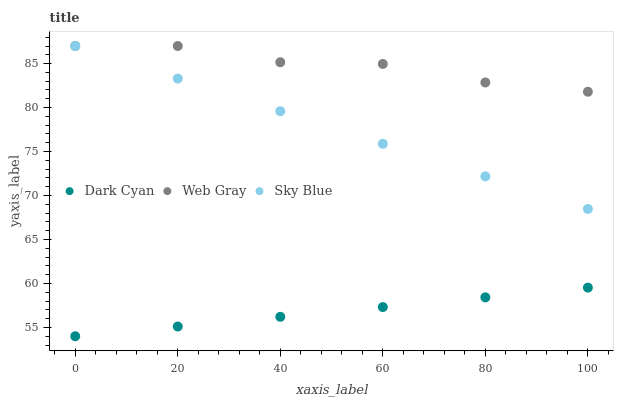Does Dark Cyan have the minimum area under the curve?
Answer yes or no. Yes. Does Web Gray have the maximum area under the curve?
Answer yes or no. Yes. Does Sky Blue have the minimum area under the curve?
Answer yes or no. No. Does Sky Blue have the maximum area under the curve?
Answer yes or no. No. Is Sky Blue the smoothest?
Answer yes or no. Yes. Is Web Gray the roughest?
Answer yes or no. Yes. Is Web Gray the smoothest?
Answer yes or no. No. Is Sky Blue the roughest?
Answer yes or no. No. Does Dark Cyan have the lowest value?
Answer yes or no. Yes. Does Sky Blue have the lowest value?
Answer yes or no. No. Does Web Gray have the highest value?
Answer yes or no. Yes. Is Dark Cyan less than Sky Blue?
Answer yes or no. Yes. Is Web Gray greater than Dark Cyan?
Answer yes or no. Yes. Does Web Gray intersect Sky Blue?
Answer yes or no. Yes. Is Web Gray less than Sky Blue?
Answer yes or no. No. Is Web Gray greater than Sky Blue?
Answer yes or no. No. Does Dark Cyan intersect Sky Blue?
Answer yes or no. No. 